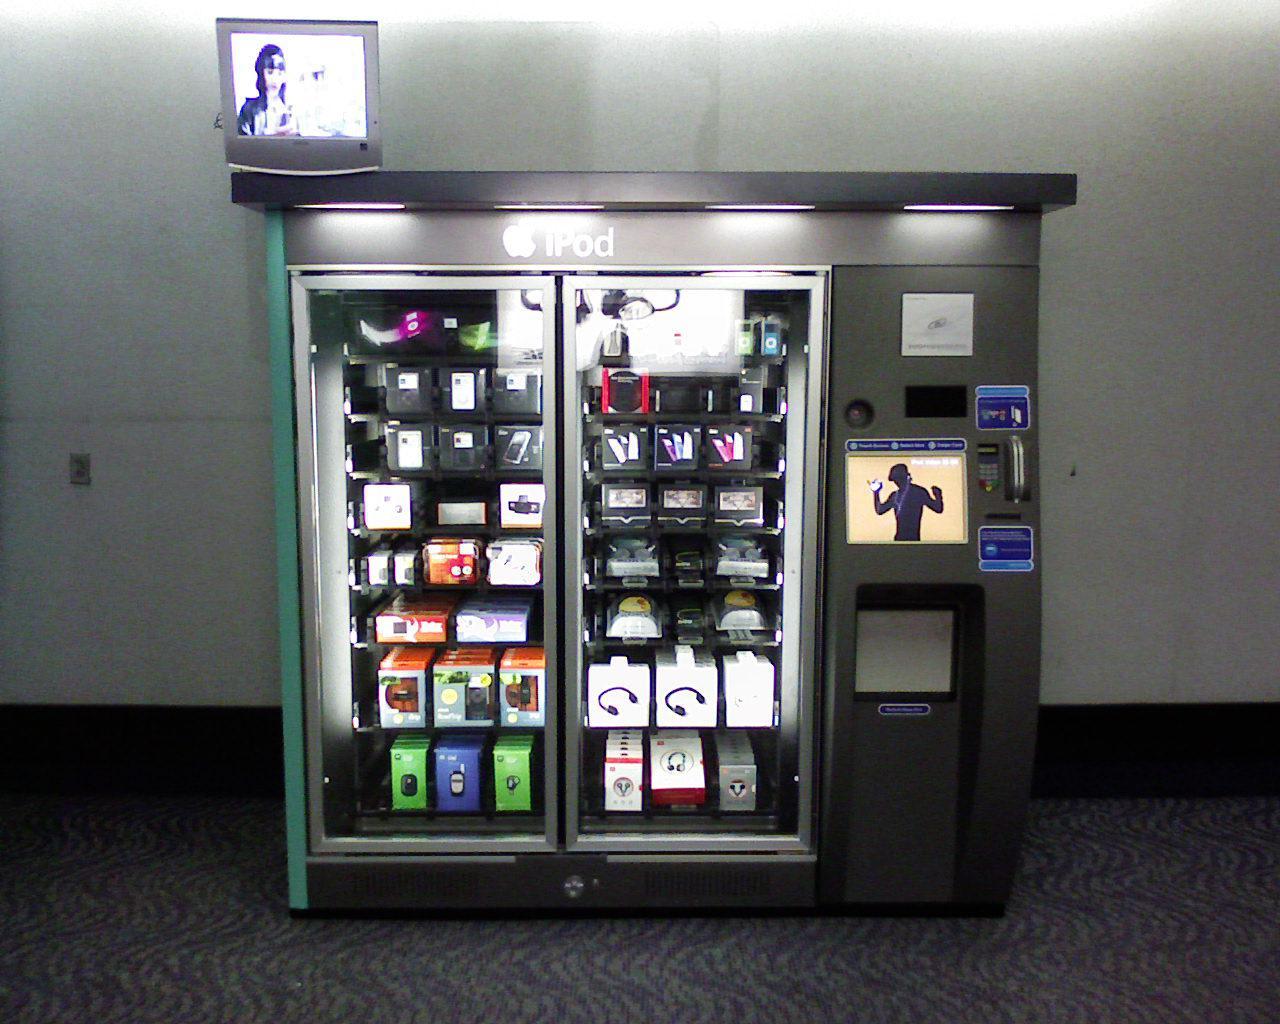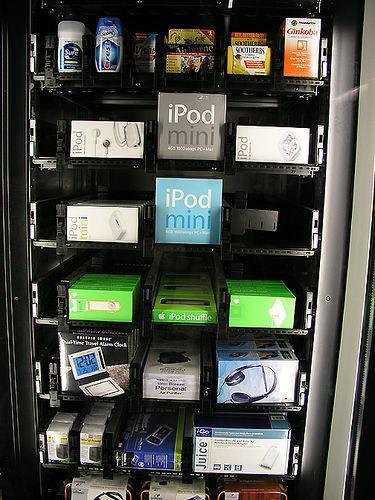The first image is the image on the left, the second image is the image on the right. For the images shown, is this caption "At least one image shows three or more vending machines." true? Answer yes or no. No. The first image is the image on the left, the second image is the image on the right. Evaluate the accuracy of this statement regarding the images: "One of the image contains one or more vending machines that are facing to the left.". Is it true? Answer yes or no. No. 